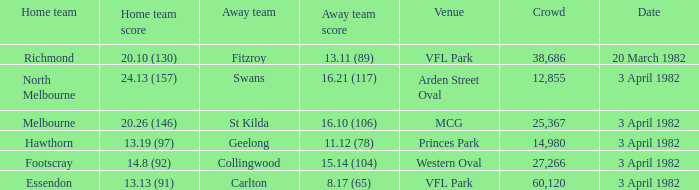When the away team scored 11.12 (78), what was the date of the game? 3 April 1982. Could you parse the entire table as a dict? {'header': ['Home team', 'Home team score', 'Away team', 'Away team score', 'Venue', 'Crowd', 'Date'], 'rows': [['Richmond', '20.10 (130)', 'Fitzroy', '13.11 (89)', 'VFL Park', '38,686', '20 March 1982'], ['North Melbourne', '24.13 (157)', 'Swans', '16.21 (117)', 'Arden Street Oval', '12,855', '3 April 1982'], ['Melbourne', '20.26 (146)', 'St Kilda', '16.10 (106)', 'MCG', '25,367', '3 April 1982'], ['Hawthorn', '13.19 (97)', 'Geelong', '11.12 (78)', 'Princes Park', '14,980', '3 April 1982'], ['Footscray', '14.8 (92)', 'Collingwood', '15.14 (104)', 'Western Oval', '27,266', '3 April 1982'], ['Essendon', '13.13 (91)', 'Carlton', '8.17 (65)', 'VFL Park', '60,120', '3 April 1982']]} 